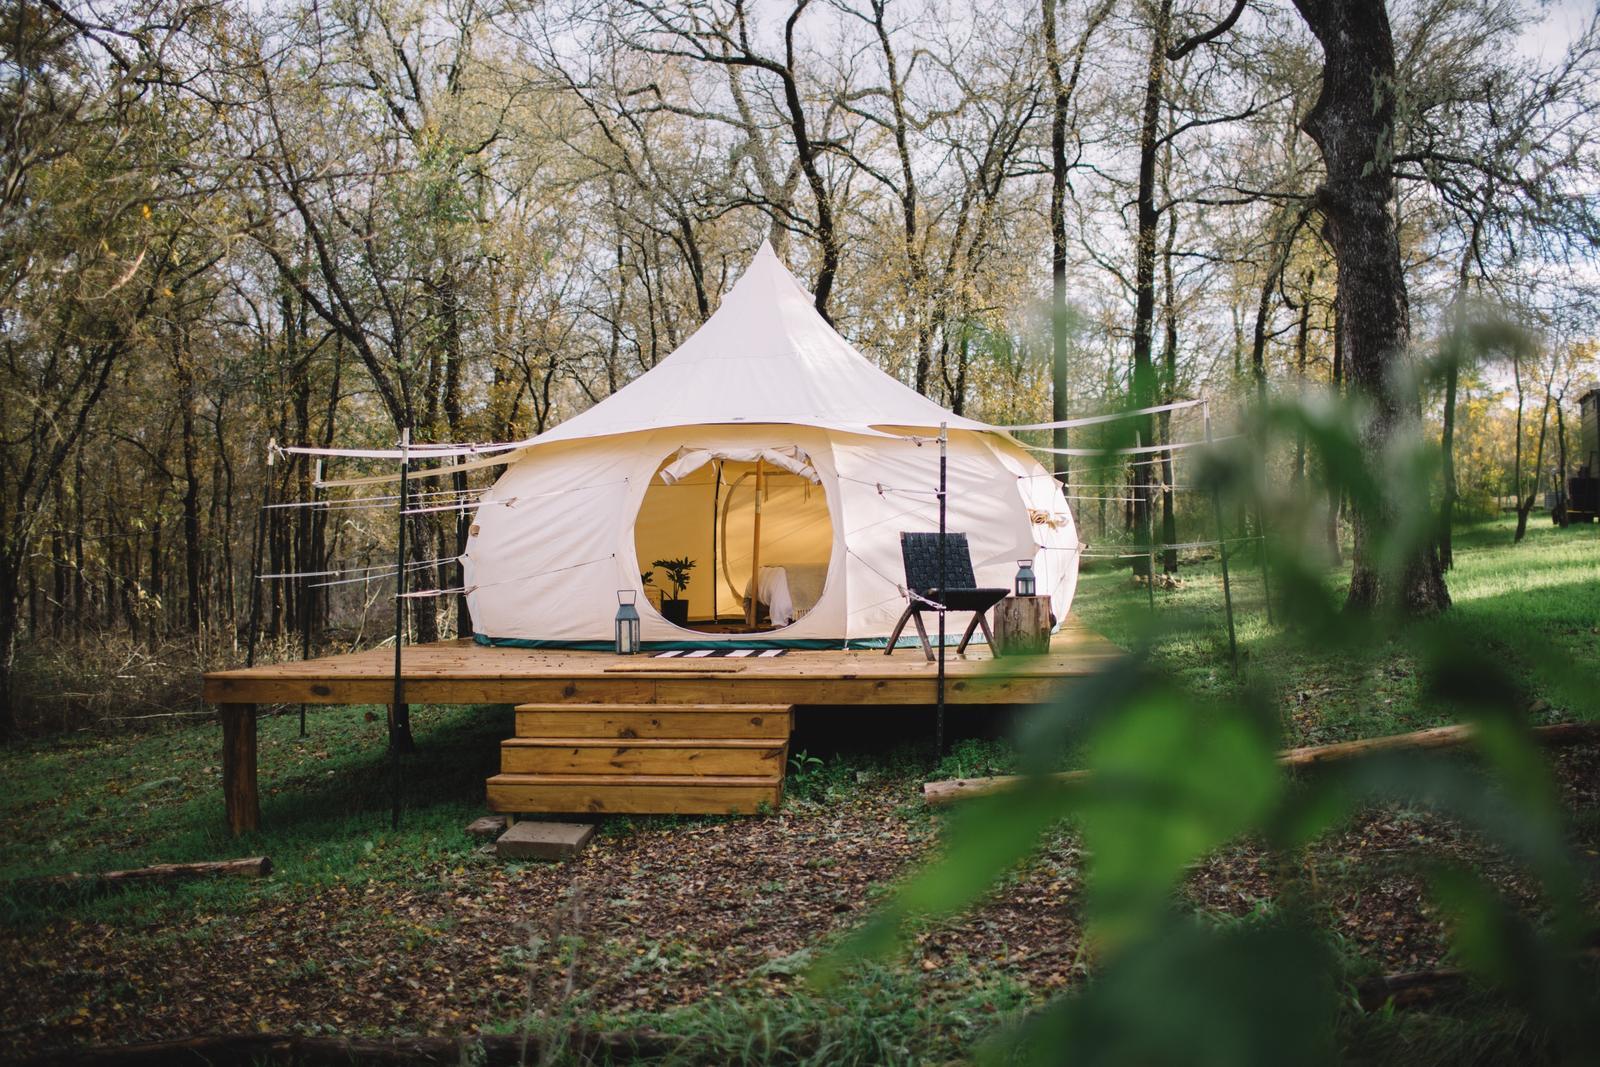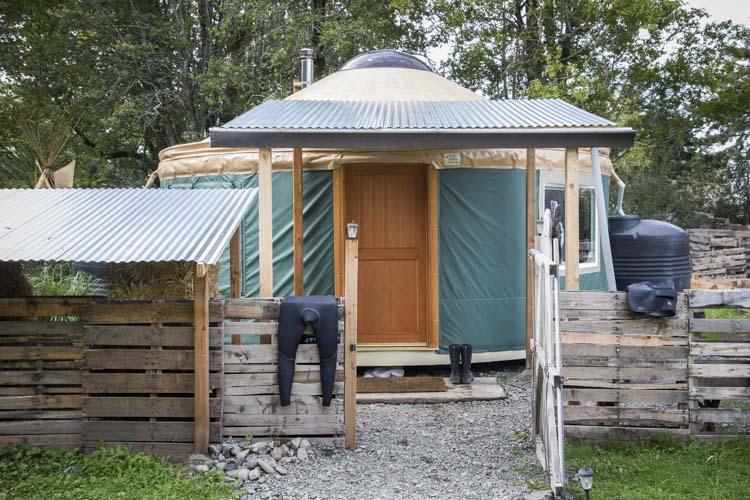The first image is the image on the left, the second image is the image on the right. Considering the images on both sides, is "At least one yurt has a set of three or four wooden stairs that leads to the door." valid? Answer yes or no. Yes. 